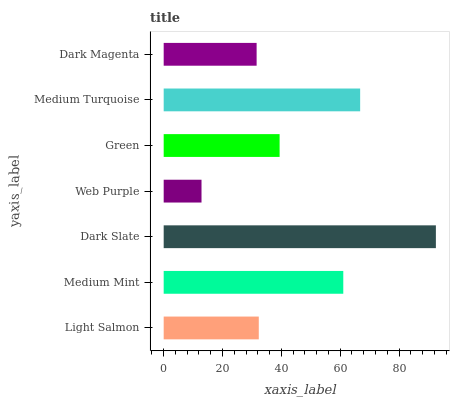Is Web Purple the minimum?
Answer yes or no. Yes. Is Dark Slate the maximum?
Answer yes or no. Yes. Is Medium Mint the minimum?
Answer yes or no. No. Is Medium Mint the maximum?
Answer yes or no. No. Is Medium Mint greater than Light Salmon?
Answer yes or no. Yes. Is Light Salmon less than Medium Mint?
Answer yes or no. Yes. Is Light Salmon greater than Medium Mint?
Answer yes or no. No. Is Medium Mint less than Light Salmon?
Answer yes or no. No. Is Green the high median?
Answer yes or no. Yes. Is Green the low median?
Answer yes or no. Yes. Is Web Purple the high median?
Answer yes or no. No. Is Dark Magenta the low median?
Answer yes or no. No. 